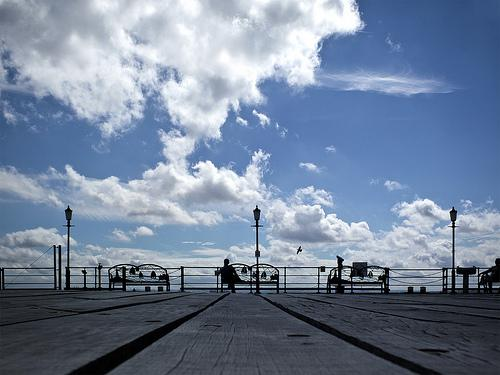Question: who is on the bench?
Choices:
A. Four children.
B. The bride and groom.
C. The business men.
D. One person.
Answer with the letter. Answer: D Question: why are there benches?
Choices:
A. So people can sit down.
B. To read the newspaper on.
C. To visit with friends.
D. To eat.
Answer with the letter. Answer: A Question: what is in the sky?
Choices:
A. Kites.
B. Clouds.
C. Stars.
D. Balloons.
Answer with the letter. Answer: B Question: where is the bench?
Choices:
A. In the park.
B. On the back porch.
C. On the pier.
D. Under the tree.
Answer with the letter. Answer: C 